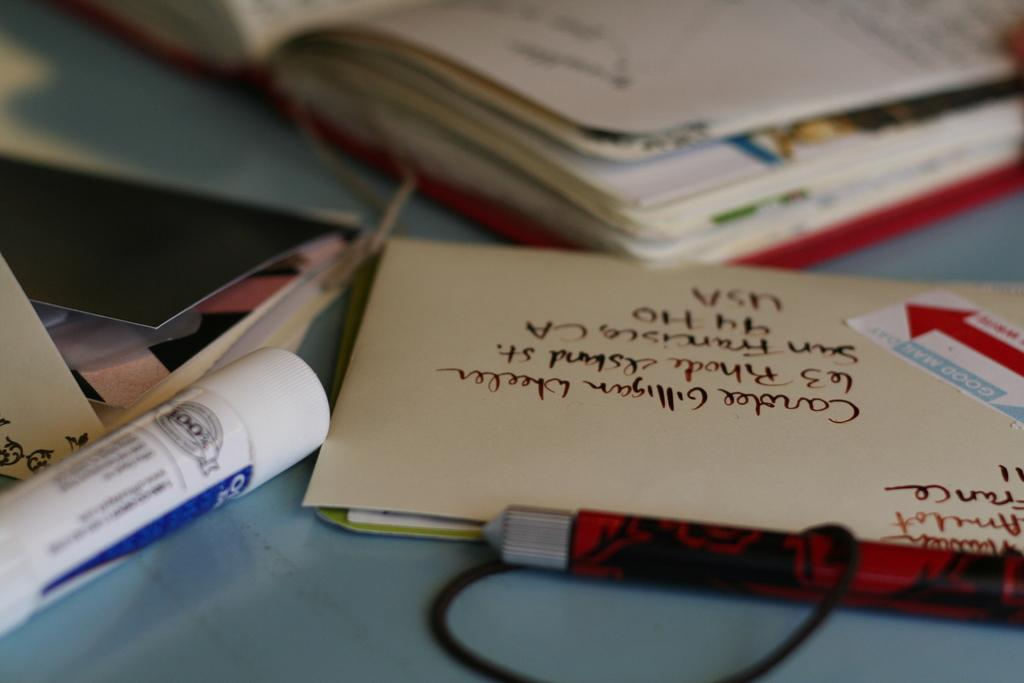<image>
Create a compact narrative representing the image presented. A USA address can be seen on an addressed envelope. 